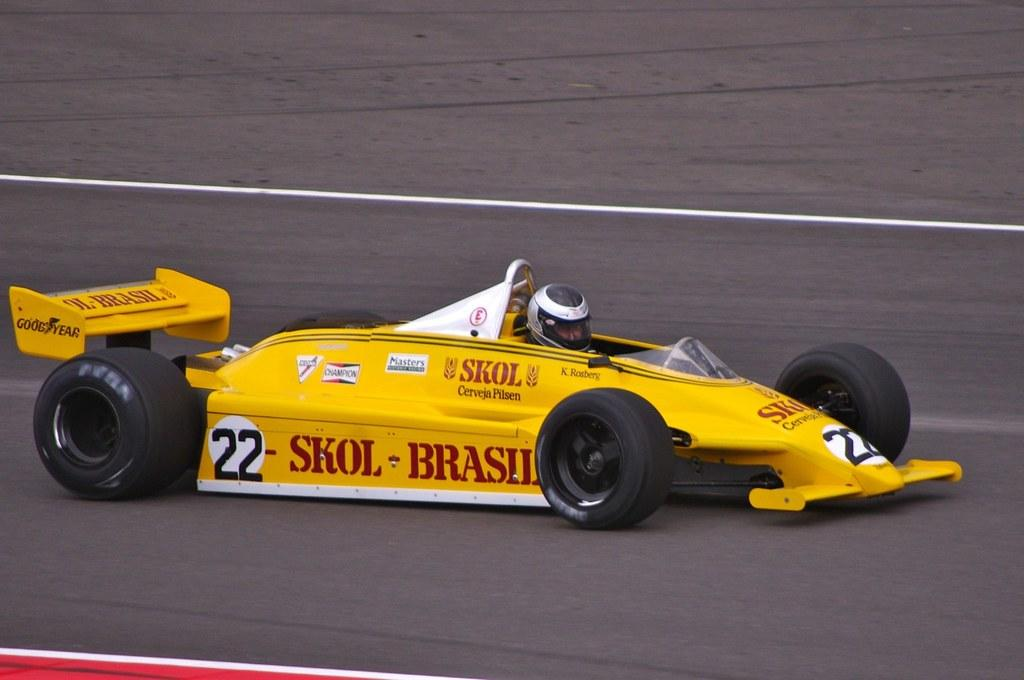What is the main subject of the image? There is a vehicle in the image. Can you describe the person in the image? There is a person in the image. What can be seen in the background of the image? There is a road visible in the background of the image. What is located at the bottom of the image? There is an object at the bottom of the image. How many sheep are visible in the image? There are no sheep present in the image. What type of desk can be seen in the image? There is no desk present in the image. 